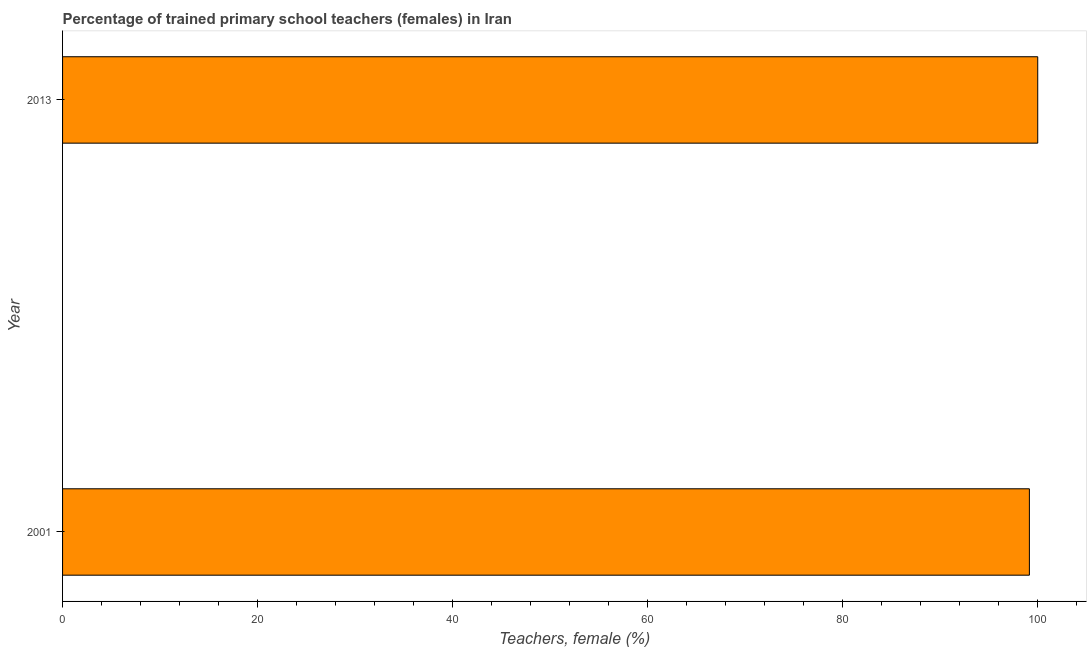Does the graph contain any zero values?
Your answer should be very brief. No. Does the graph contain grids?
Make the answer very short. No. What is the title of the graph?
Give a very brief answer. Percentage of trained primary school teachers (females) in Iran. What is the label or title of the X-axis?
Provide a succinct answer. Teachers, female (%). What is the label or title of the Y-axis?
Your answer should be compact. Year. What is the percentage of trained female teachers in 2013?
Ensure brevity in your answer.  100. Across all years, what is the maximum percentage of trained female teachers?
Your answer should be very brief. 100. Across all years, what is the minimum percentage of trained female teachers?
Your answer should be very brief. 99.14. In which year was the percentage of trained female teachers maximum?
Ensure brevity in your answer.  2013. In which year was the percentage of trained female teachers minimum?
Give a very brief answer. 2001. What is the sum of the percentage of trained female teachers?
Provide a succinct answer. 199.14. What is the difference between the percentage of trained female teachers in 2001 and 2013?
Your response must be concise. -0.86. What is the average percentage of trained female teachers per year?
Ensure brevity in your answer.  99.57. What is the median percentage of trained female teachers?
Make the answer very short. 99.57. In how many years, is the percentage of trained female teachers greater than 92 %?
Provide a short and direct response. 2. What is the ratio of the percentage of trained female teachers in 2001 to that in 2013?
Your answer should be compact. 0.99. Is the percentage of trained female teachers in 2001 less than that in 2013?
Offer a terse response. Yes. How many bars are there?
Make the answer very short. 2. Are all the bars in the graph horizontal?
Keep it short and to the point. Yes. Are the values on the major ticks of X-axis written in scientific E-notation?
Your response must be concise. No. What is the Teachers, female (%) of 2001?
Your response must be concise. 99.14. What is the Teachers, female (%) of 2013?
Make the answer very short. 100. What is the difference between the Teachers, female (%) in 2001 and 2013?
Ensure brevity in your answer.  -0.86. What is the ratio of the Teachers, female (%) in 2001 to that in 2013?
Make the answer very short. 0.99. 